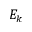Convert formula to latex. <formula><loc_0><loc_0><loc_500><loc_500>E _ { k }</formula> 